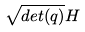Convert formula to latex. <formula><loc_0><loc_0><loc_500><loc_500>\sqrt { d e t ( q ) } H</formula> 